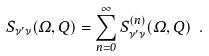Convert formula to latex. <formula><loc_0><loc_0><loc_500><loc_500>S _ { \nu ^ { \prime } \nu } ( \Omega , Q ) = \sum _ { n = 0 } ^ { \infty } S _ { \nu ^ { \prime } \nu } ^ { ( n ) } ( \Omega , Q ) \ .</formula> 